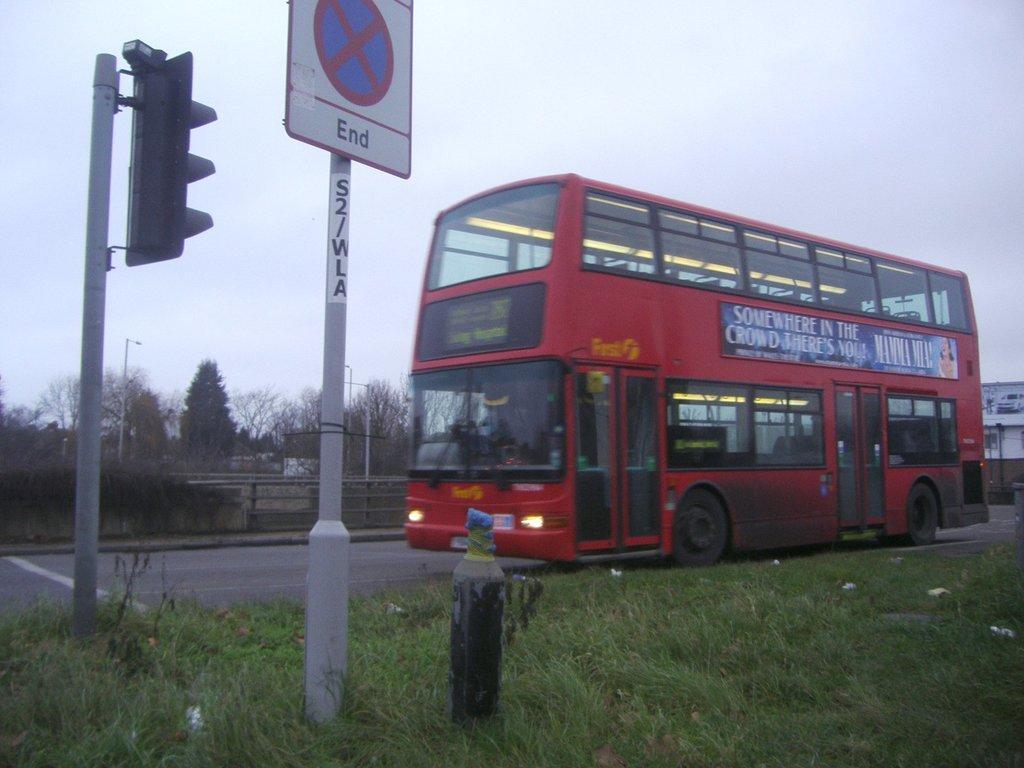Can you describe this image briefly? In this picture, there is a double Decker bus on the road which is towards the right and it is facing towards the left. It is in red in color. At the bottom, there is grass. Towards the left, there is a signal light and a pole. In the background there are trees, buildings and a sky. 